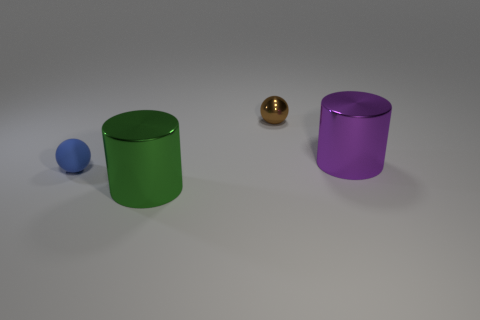Add 2 big purple cylinders. How many objects exist? 6 Add 4 large purple cylinders. How many large purple cylinders exist? 5 Subtract 0 brown cylinders. How many objects are left? 4 Subtract all green metallic cylinders. Subtract all balls. How many objects are left? 1 Add 3 balls. How many balls are left? 5 